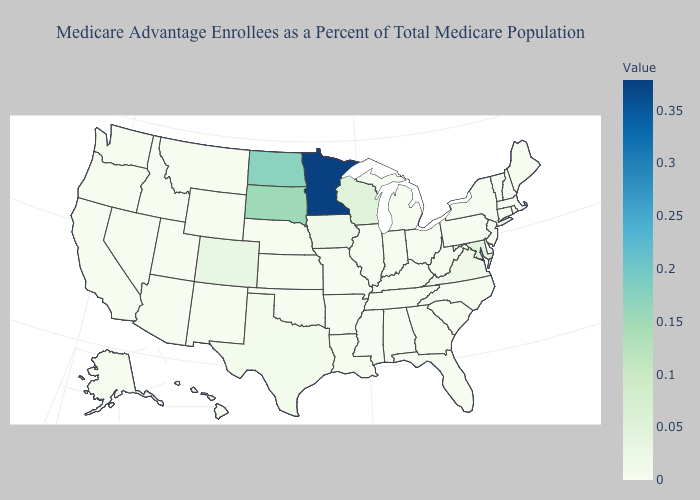Does Minnesota have the lowest value in the MidWest?
Be succinct. No. Does the map have missing data?
Be succinct. No. Which states have the lowest value in the Northeast?
Keep it brief. Connecticut, Massachusetts, Maine, New Hampshire, New Jersey, Pennsylvania, Rhode Island, Vermont. Which states have the lowest value in the USA?
Quick response, please. Alaska, Alabama, Arkansas, Connecticut, Delaware, Florida, Georgia, Hawaii, Idaho, Indiana, Kansas, Kentucky, Louisiana, Massachusetts, Maine, Michigan, Missouri, Mississippi, Montana, North Carolina, New Hampshire, New Jersey, New Mexico, Nevada, Oklahoma, Oregon, Pennsylvania, Rhode Island, South Carolina, Tennessee, Utah, Vermont, Washington, West Virginia, Wyoming. Does Maryland have the highest value in the South?
Answer briefly. Yes. Is the legend a continuous bar?
Keep it brief. Yes. Which states have the lowest value in the West?
Write a very short answer. Alaska, Hawaii, Idaho, Montana, New Mexico, Nevada, Oregon, Utah, Washington, Wyoming. 